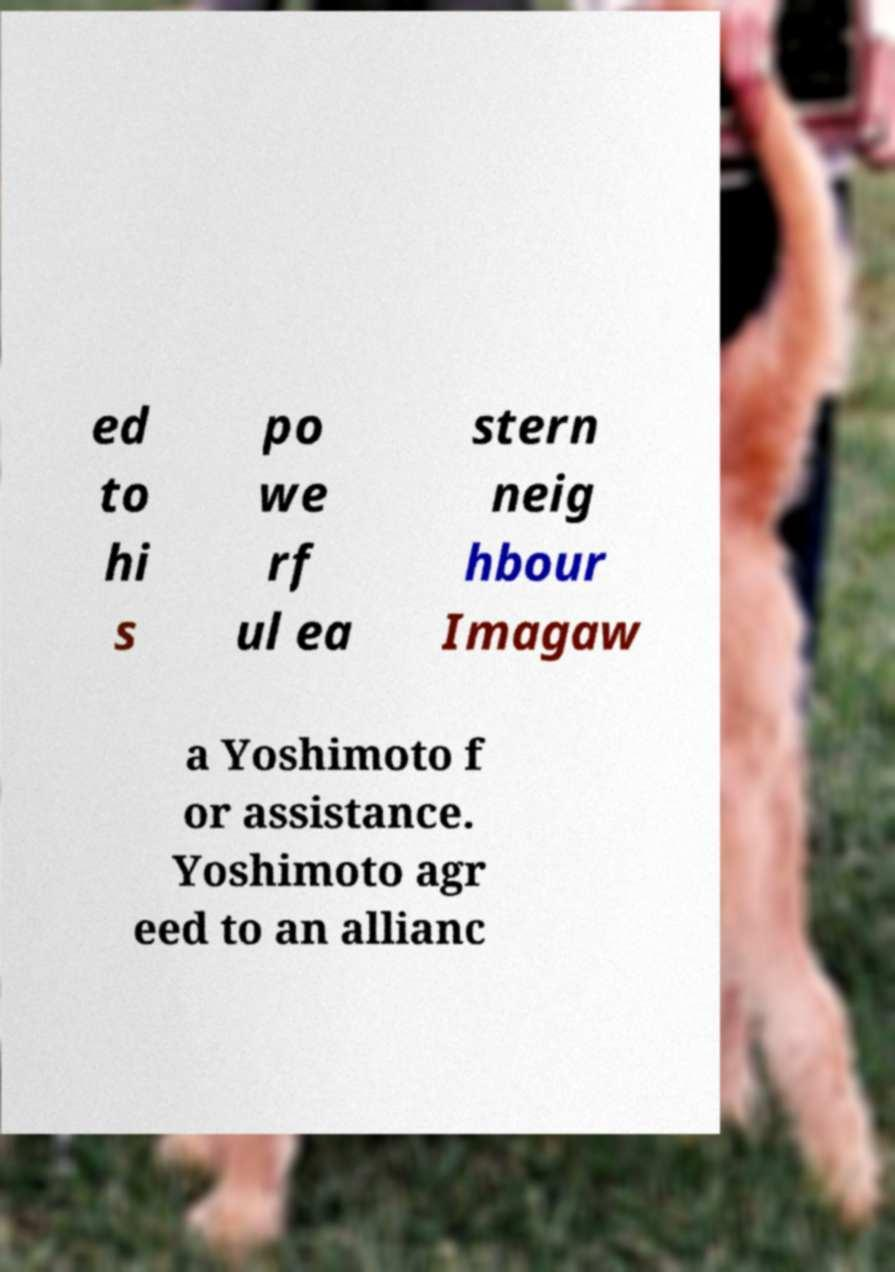Can you accurately transcribe the text from the provided image for me? ed to hi s po we rf ul ea stern neig hbour Imagaw a Yoshimoto f or assistance. Yoshimoto agr eed to an allianc 